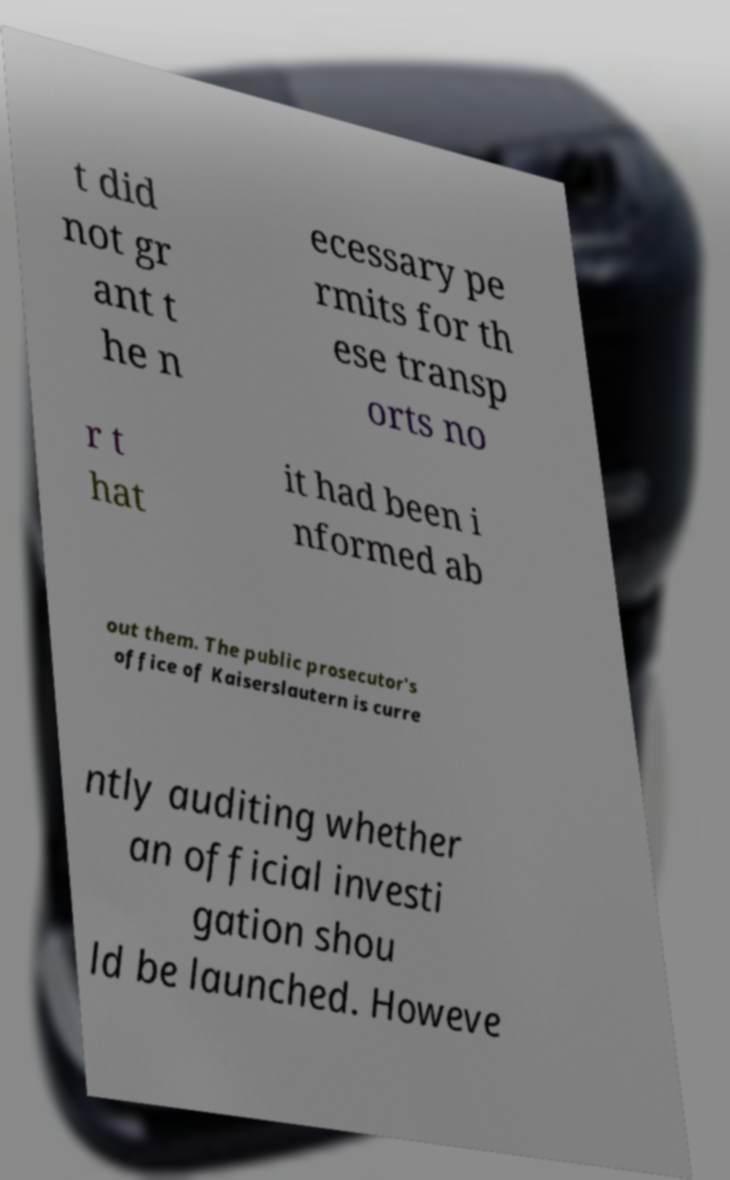I need the written content from this picture converted into text. Can you do that? t did not gr ant t he n ecessary pe rmits for th ese transp orts no r t hat it had been i nformed ab out them. The public prosecutor's office of Kaiserslautern is curre ntly auditing whether an official investi gation shou ld be launched. Howeve 